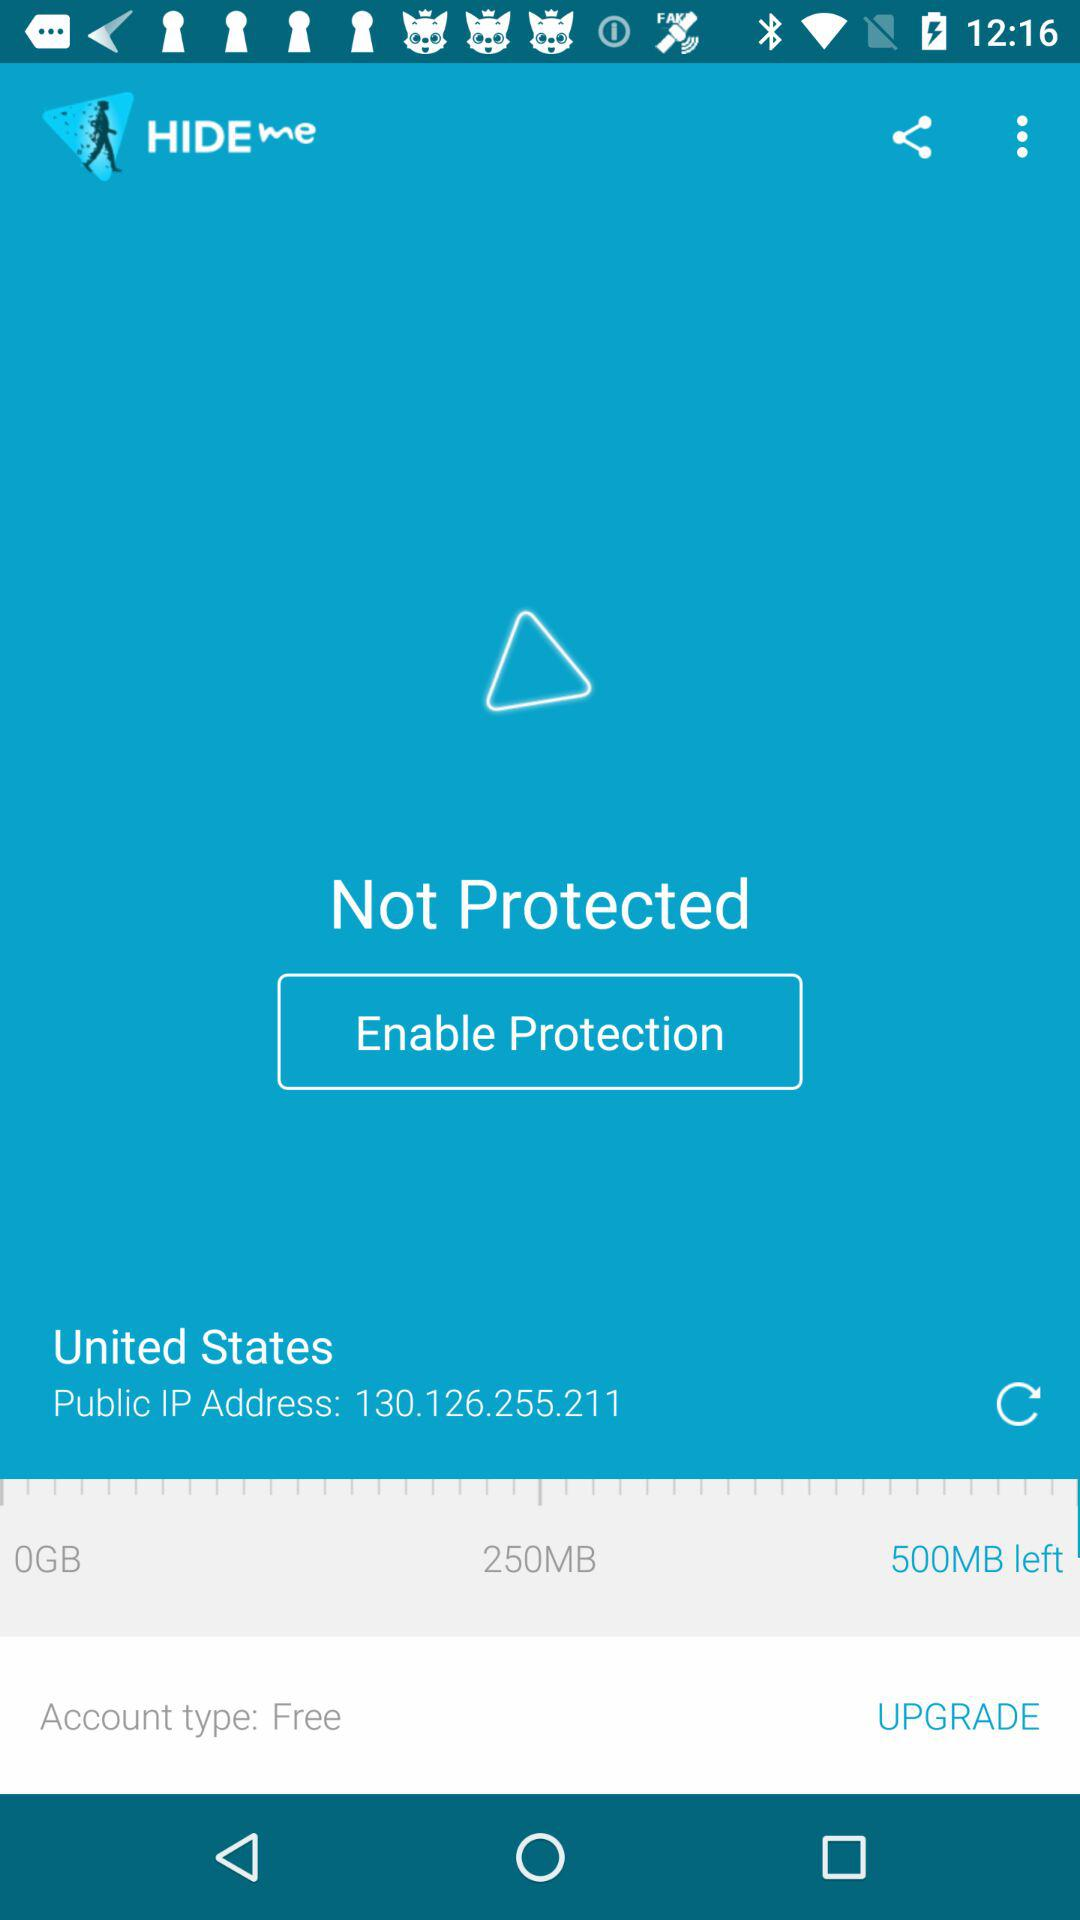Which country is the IP address from? The IP address is from the United States. 